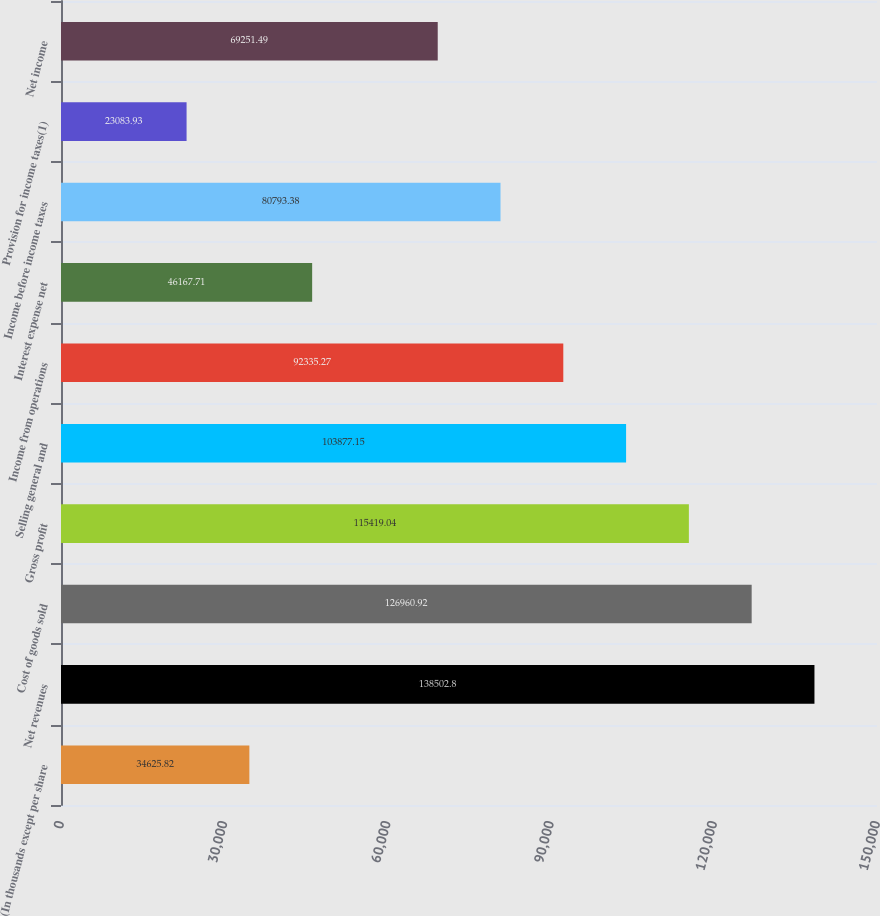<chart> <loc_0><loc_0><loc_500><loc_500><bar_chart><fcel>(In thousands except per share<fcel>Net revenues<fcel>Cost of goods sold<fcel>Gross profit<fcel>Selling general and<fcel>Income from operations<fcel>Interest expense net<fcel>Income before income taxes<fcel>Provision for income taxes(1)<fcel>Net income<nl><fcel>34625.8<fcel>138503<fcel>126961<fcel>115419<fcel>103877<fcel>92335.3<fcel>46167.7<fcel>80793.4<fcel>23083.9<fcel>69251.5<nl></chart> 